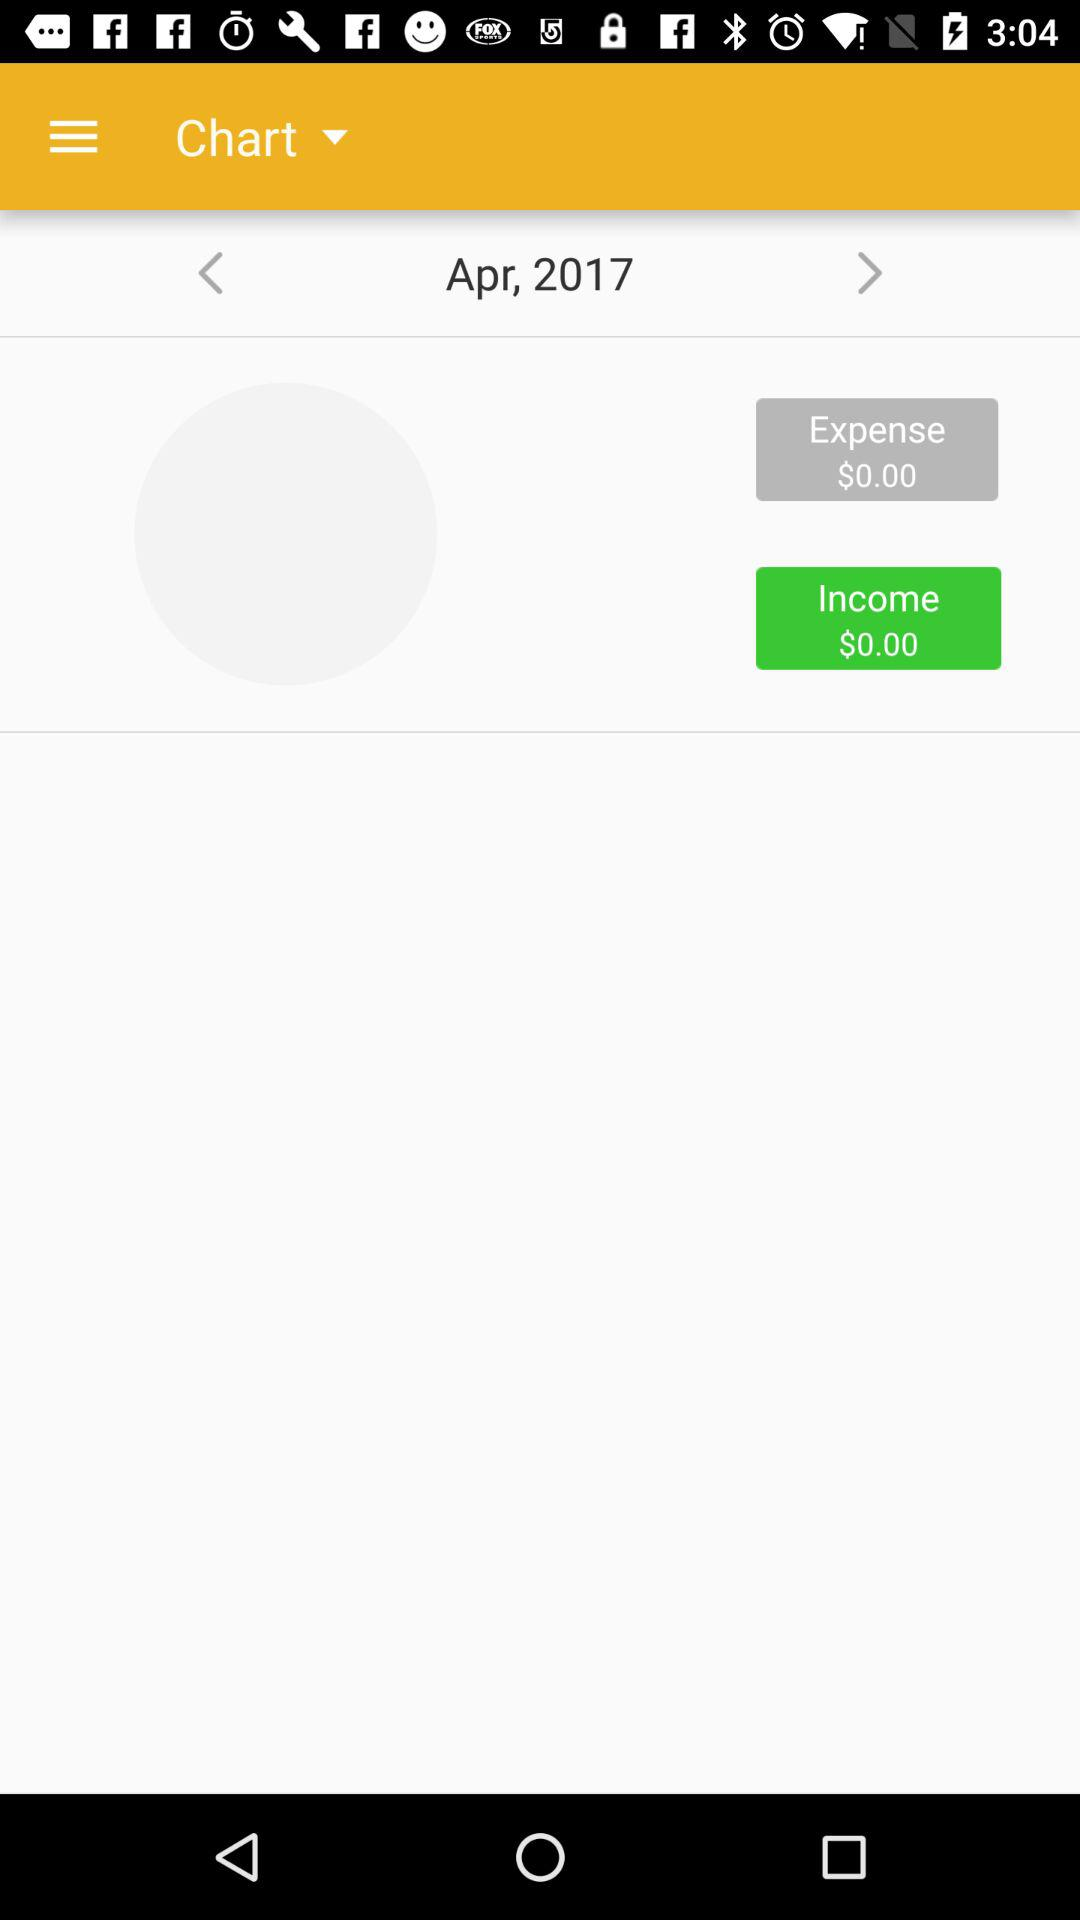How many months are represented in the chart?
Answer the question using a single word or phrase. 1 